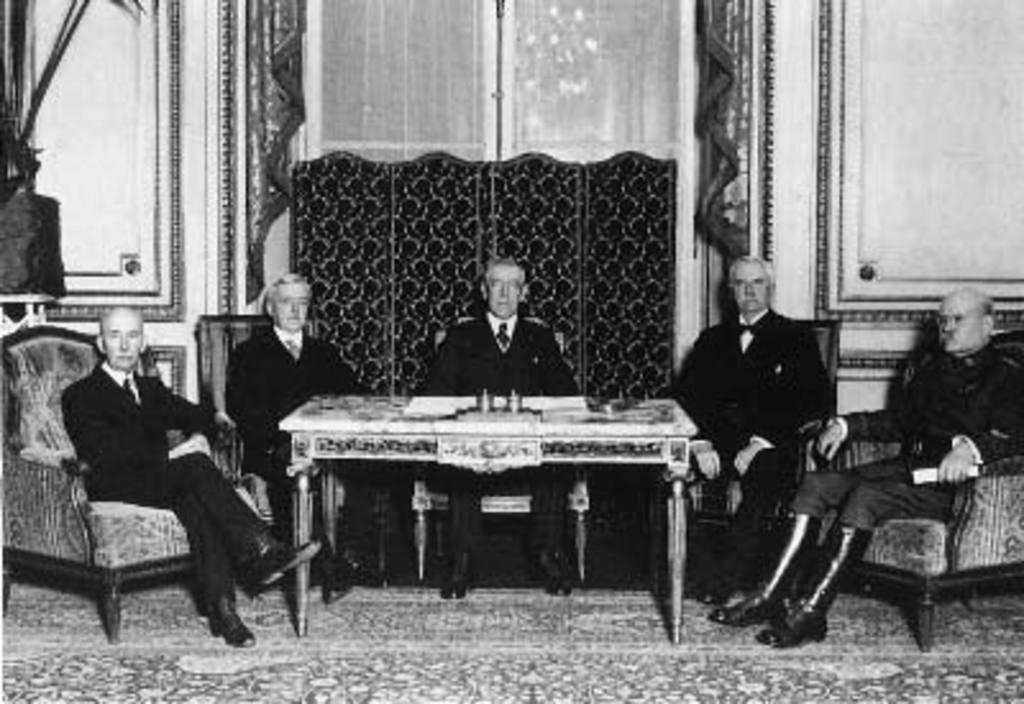What is the color scheme of the image? The image is black and white. How many people are in the image? There are five men in the image. What are the men doing in the image? The men are sitting on chairs. What is located behind the men in the image? The men are in front of a table. What is the weight of the blade in the image? There is no blade present in the image. 